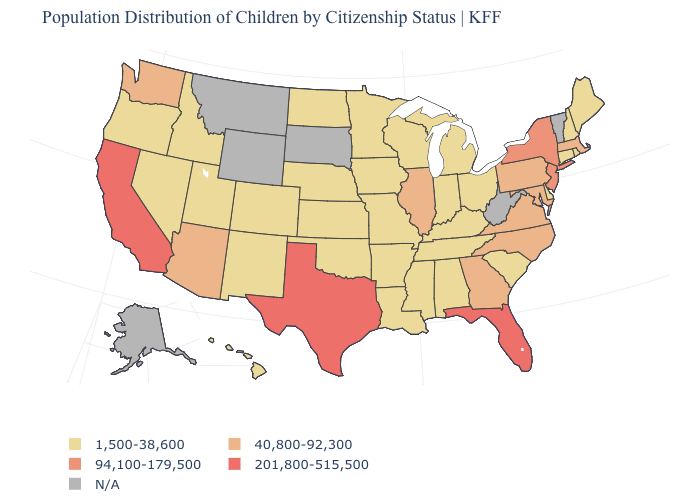What is the highest value in the USA?
Be succinct. 201,800-515,500. What is the value of Nevada?
Answer briefly. 1,500-38,600. Name the states that have a value in the range 40,800-92,300?
Short answer required. Arizona, Georgia, Illinois, Maryland, Massachusetts, North Carolina, Pennsylvania, Virginia, Washington. Name the states that have a value in the range 1,500-38,600?
Be succinct. Alabama, Arkansas, Colorado, Connecticut, Delaware, Hawaii, Idaho, Indiana, Iowa, Kansas, Kentucky, Louisiana, Maine, Michigan, Minnesota, Mississippi, Missouri, Nebraska, Nevada, New Hampshire, New Mexico, North Dakota, Ohio, Oklahoma, Oregon, Rhode Island, South Carolina, Tennessee, Utah, Wisconsin. Among the states that border Delaware , which have the lowest value?
Concise answer only. Maryland, Pennsylvania. Does Illinois have the lowest value in the MidWest?
Keep it brief. No. Which states have the lowest value in the USA?
Quick response, please. Alabama, Arkansas, Colorado, Connecticut, Delaware, Hawaii, Idaho, Indiana, Iowa, Kansas, Kentucky, Louisiana, Maine, Michigan, Minnesota, Mississippi, Missouri, Nebraska, Nevada, New Hampshire, New Mexico, North Dakota, Ohio, Oklahoma, Oregon, Rhode Island, South Carolina, Tennessee, Utah, Wisconsin. Name the states that have a value in the range N/A?
Quick response, please. Alaska, Montana, South Dakota, Vermont, West Virginia, Wyoming. Does Illinois have the highest value in the MidWest?
Be succinct. Yes. How many symbols are there in the legend?
Write a very short answer. 5. Does Louisiana have the lowest value in the South?
Keep it brief. Yes. What is the highest value in the USA?
Be succinct. 201,800-515,500. What is the value of Missouri?
Short answer required. 1,500-38,600. Does Virginia have the lowest value in the USA?
Quick response, please. No. 